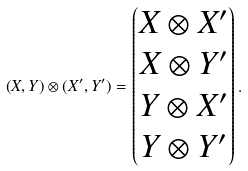<formula> <loc_0><loc_0><loc_500><loc_500>( X , Y ) \otimes ( X ^ { \prime } , Y ^ { \prime } ) = \begin{pmatrix} X \otimes X ^ { \prime } \\ X \otimes Y ^ { \prime } \\ Y \otimes X ^ { \prime } \\ Y \otimes Y ^ { \prime } \end{pmatrix} .</formula> 